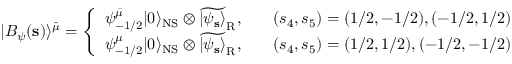<formula> <loc_0><loc_0><loc_500><loc_500>| B _ { \psi } ( { s } ) \rangle ^ { \hat { \mu } } = \left \{ \begin{array} { l l } { { \psi _ { - 1 / 2 } ^ { \bar { \mu } } | 0 \rangle _ { N S } \otimes \widetilde { | \psi _ { s } \rangle } _ { R } , } } & { { \quad ( s _ { 4 } , s _ { 5 } ) = ( 1 / 2 , - 1 / 2 ) , ( - 1 / 2 , 1 / 2 ) } } \\ { { \psi _ { - 1 / 2 } ^ { \mu } | 0 \rangle _ { N S } \otimes \widetilde { | \psi _ { s } \rangle } _ { R } , } } & { { \quad ( s _ { 4 } , s _ { 5 } ) = ( 1 / 2 , 1 / 2 ) , ( - 1 / 2 , - 1 / 2 ) } } \end{array}</formula> 